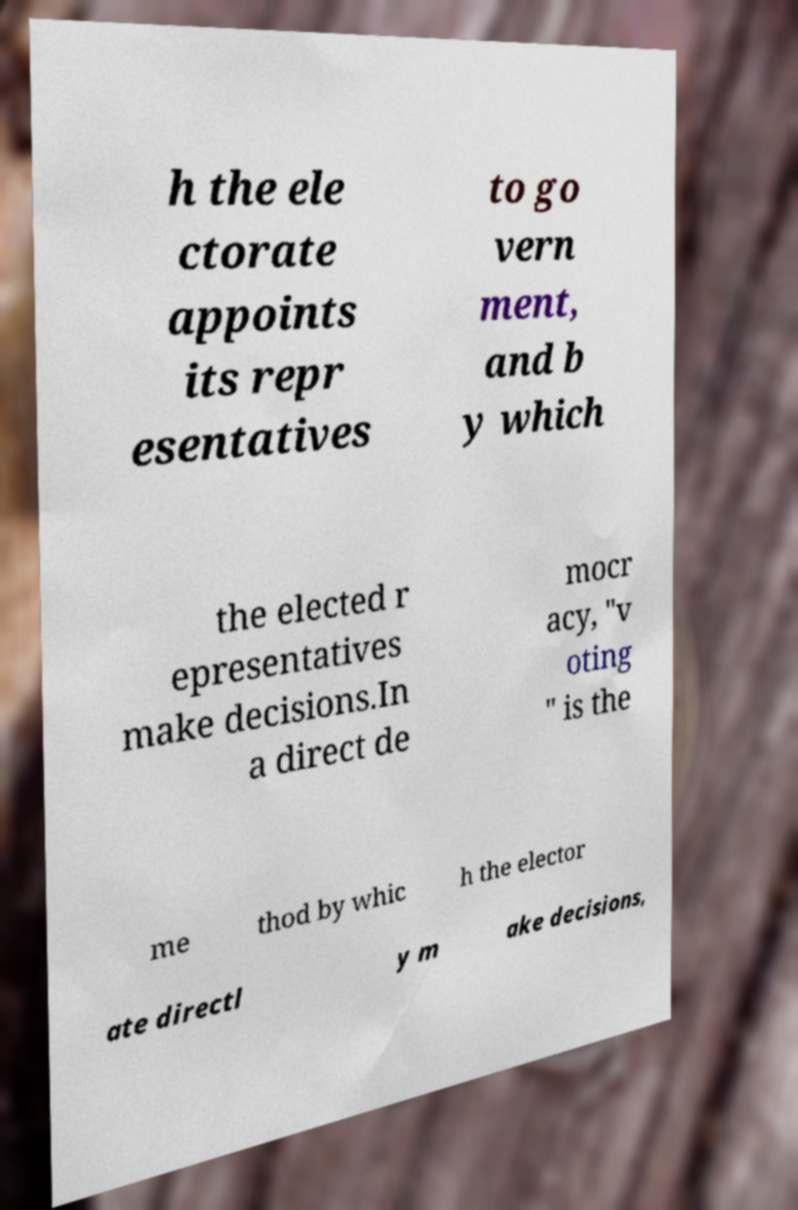For documentation purposes, I need the text within this image transcribed. Could you provide that? h the ele ctorate appoints its repr esentatives to go vern ment, and b y which the elected r epresentatives make decisions.In a direct de mocr acy, "v oting " is the me thod by whic h the elector ate directl y m ake decisions, 